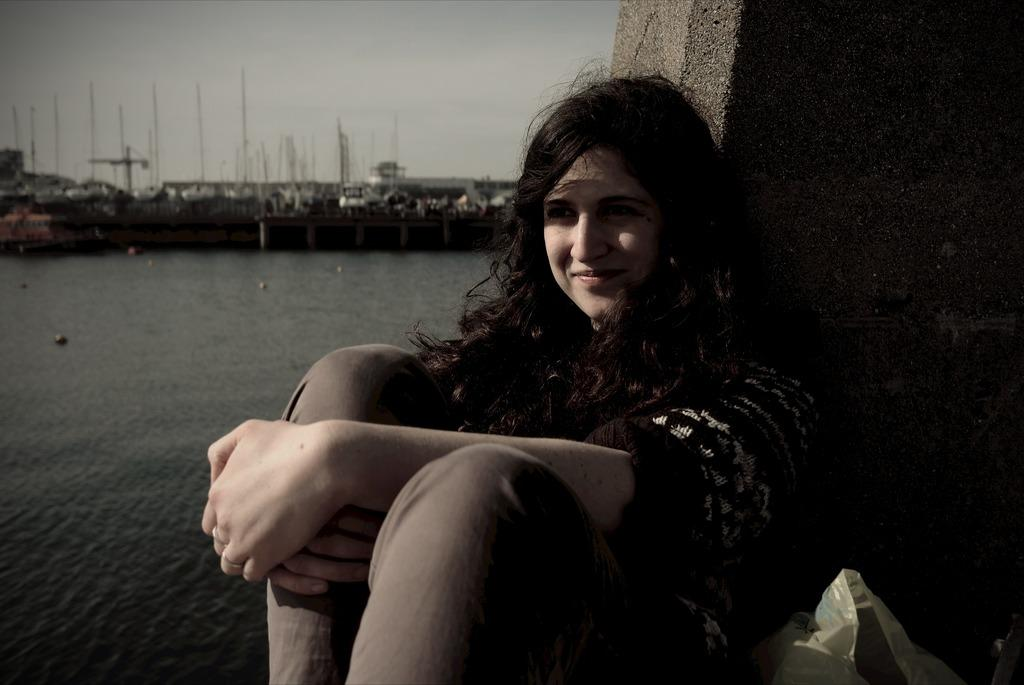What is the woman in the image doing? The woman is sitting on the ground in the image. What can be seen in the background of the image? There is water, a bridge, a harbor, and the sky visible in the background of the image. What type of stamp can be seen on the rabbits in the image? There are no rabbits or stamps present in the image. What language is the woman speaking in the image? The image does not provide any information about the language being spoken by the woman. 